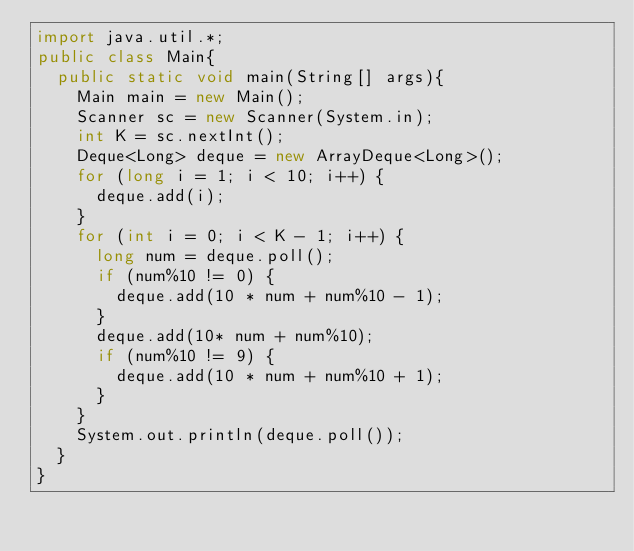<code> <loc_0><loc_0><loc_500><loc_500><_Java_>import java.util.*;
public class Main{
	public static void main(String[] args){
		Main main = new Main();
		Scanner sc = new Scanner(System.in);
		int K = sc.nextInt();
		Deque<Long> deque = new ArrayDeque<Long>();
		for (long i = 1; i < 10; i++) {
			deque.add(i);
		}
		for (int i = 0; i < K - 1; i++) {
			long num = deque.poll();
			if (num%10 != 0) {
				deque.add(10 * num + num%10 - 1);
			}
			deque.add(10* num + num%10);
			if (num%10 != 9) {
				deque.add(10 * num + num%10 + 1);
			}
		}
		System.out.println(deque.poll());
	}
}</code> 